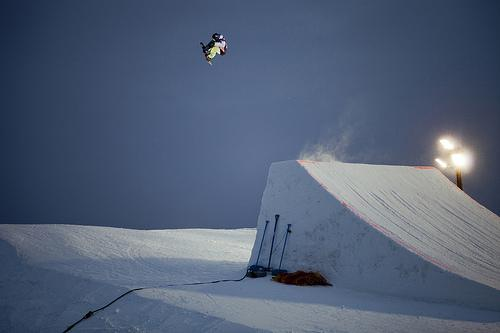Question: where was the picture taken?
Choices:
A. At a snowboarding course.
B. At a skating rink.
C. At a skateboard park.
D. At a swimming pool.
Answer with the letter. Answer: A Question: what is in the air?
Choices:
A. Cat.
B. A dog.
C. Bird.
D. Penguin.
Answer with the letter. Answer: B Question: why is it on air?
Choices:
A. It flew.
B. It has wings.
C. It is a robot.
D. It has jumped.
Answer with the letter. Answer: D Question: when was the pic taken?
Choices:
A. At night.
B. Day.
C. Morning.
D. Afternoon.
Answer with the letter. Answer: A 